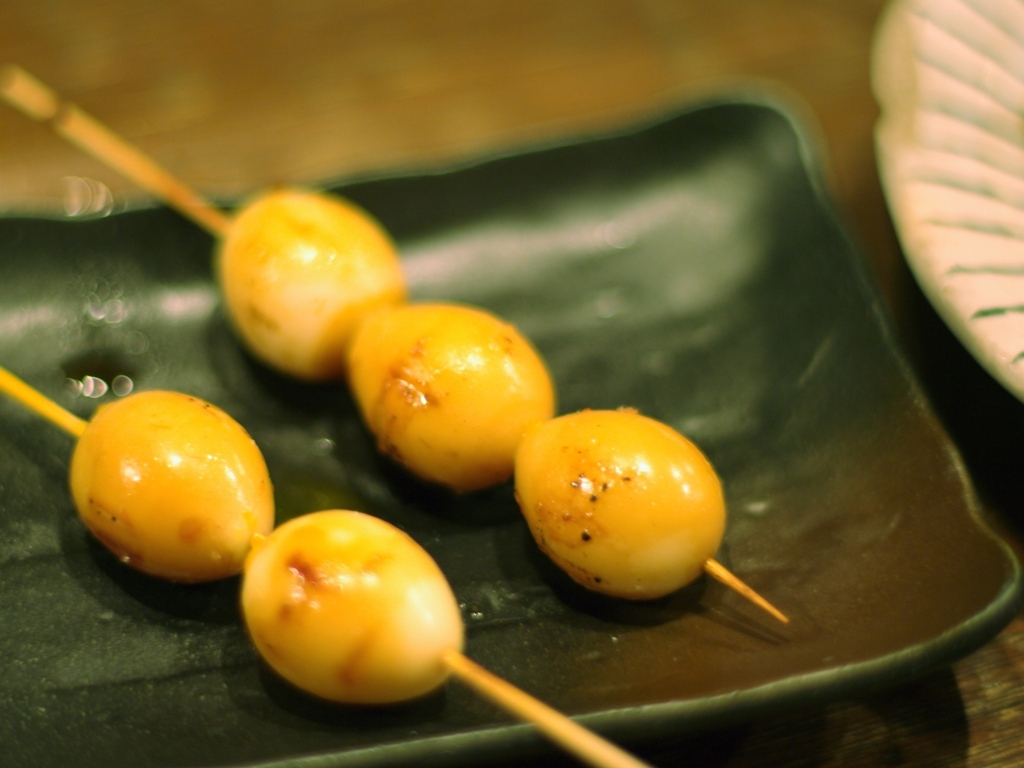How would you describe the lighting of the overall picture?
A. overexposed
B. well-lit
C. dimly lit
D. dark
Answer with the option's letter from the given choices directly.
 B. 